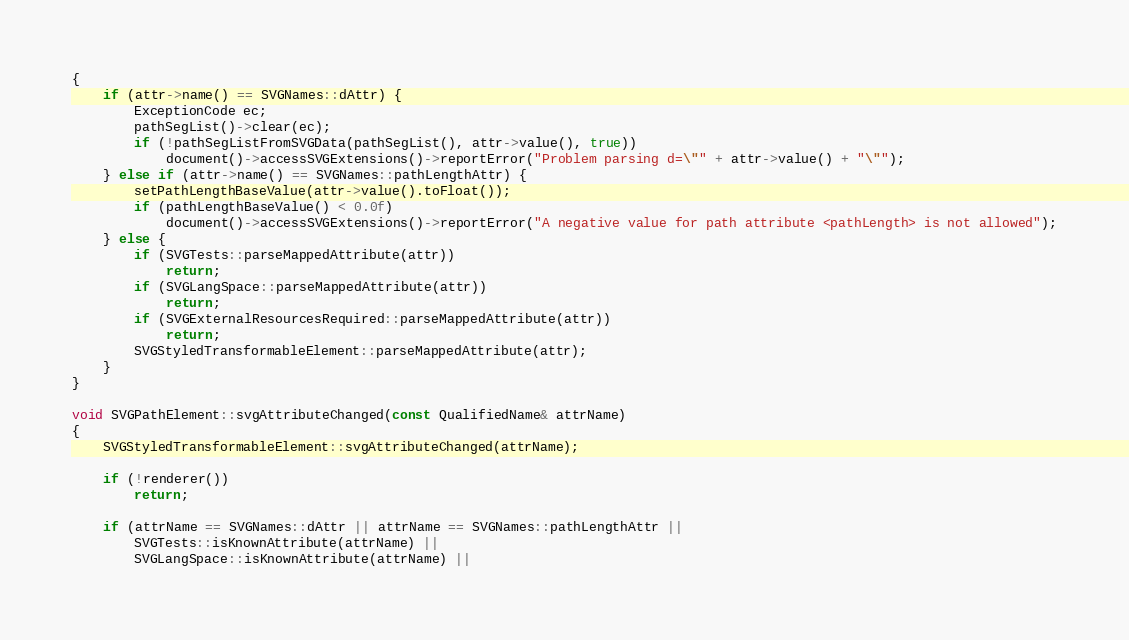Convert code to text. <code><loc_0><loc_0><loc_500><loc_500><_C++_>{
    if (attr->name() == SVGNames::dAttr) {
        ExceptionCode ec;
        pathSegList()->clear(ec);
        if (!pathSegListFromSVGData(pathSegList(), attr->value(), true))
            document()->accessSVGExtensions()->reportError("Problem parsing d=\"" + attr->value() + "\"");
    } else if (attr->name() == SVGNames::pathLengthAttr) {
        setPathLengthBaseValue(attr->value().toFloat());
        if (pathLengthBaseValue() < 0.0f)
            document()->accessSVGExtensions()->reportError("A negative value for path attribute <pathLength> is not allowed");
    } else {
        if (SVGTests::parseMappedAttribute(attr))
            return;
        if (SVGLangSpace::parseMappedAttribute(attr))
            return;
        if (SVGExternalResourcesRequired::parseMappedAttribute(attr))
            return;
        SVGStyledTransformableElement::parseMappedAttribute(attr);
    }
}

void SVGPathElement::svgAttributeChanged(const QualifiedName& attrName)
{
    SVGStyledTransformableElement::svgAttributeChanged(attrName);

    if (!renderer())
        return;

    if (attrName == SVGNames::dAttr || attrName == SVGNames::pathLengthAttr ||
        SVGTests::isKnownAttribute(attrName) ||
        SVGLangSpace::isKnownAttribute(attrName) ||</code> 